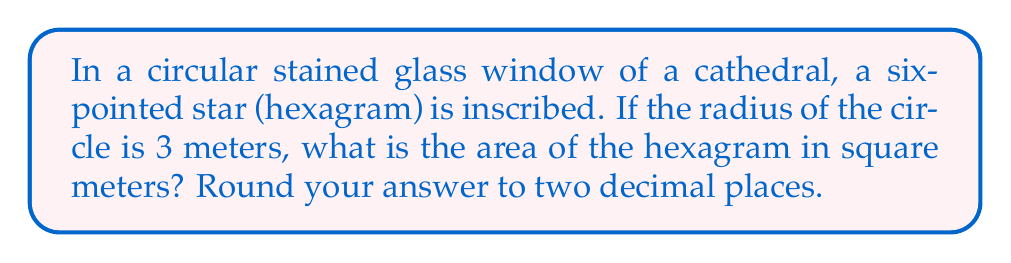Help me with this question. Let's approach this step-by-step:

1) A hexagram is composed of two equilateral triangles. We need to find the area of these triangles.

2) In a circle with radius $r$, the side length $s$ of an inscribed equilateral triangle is:

   $$s = r\sqrt{3}$$

3) With $r = 3$ meters, the side length is:

   $$s = 3\sqrt{3}$$ meters

4) The area $A$ of an equilateral triangle with side $s$ is:

   $$A = \frac{\sqrt{3}}{4}s^2$$

5) Substituting our side length:

   $$A = \frac{\sqrt{3}}{4}(3\sqrt{3})^2 = \frac{\sqrt{3}}{4} \cdot 27 \cdot 3 = \frac{81\sqrt{3}}{4}$$ square meters

6) The hexagram consists of two such triangles, so its total area is:

   $$A_{hexagram} = 2 \cdot \frac{81\sqrt{3}}{4} = \frac{81\sqrt{3}}{2} \approx 70.19$$ square meters

7) Rounding to two decimal places, we get 70.19 square meters.

This problem illustrates the geometric symmetry often found in religious art, particularly in windows and other architectural features of places of worship.
Answer: 70.19 square meters 